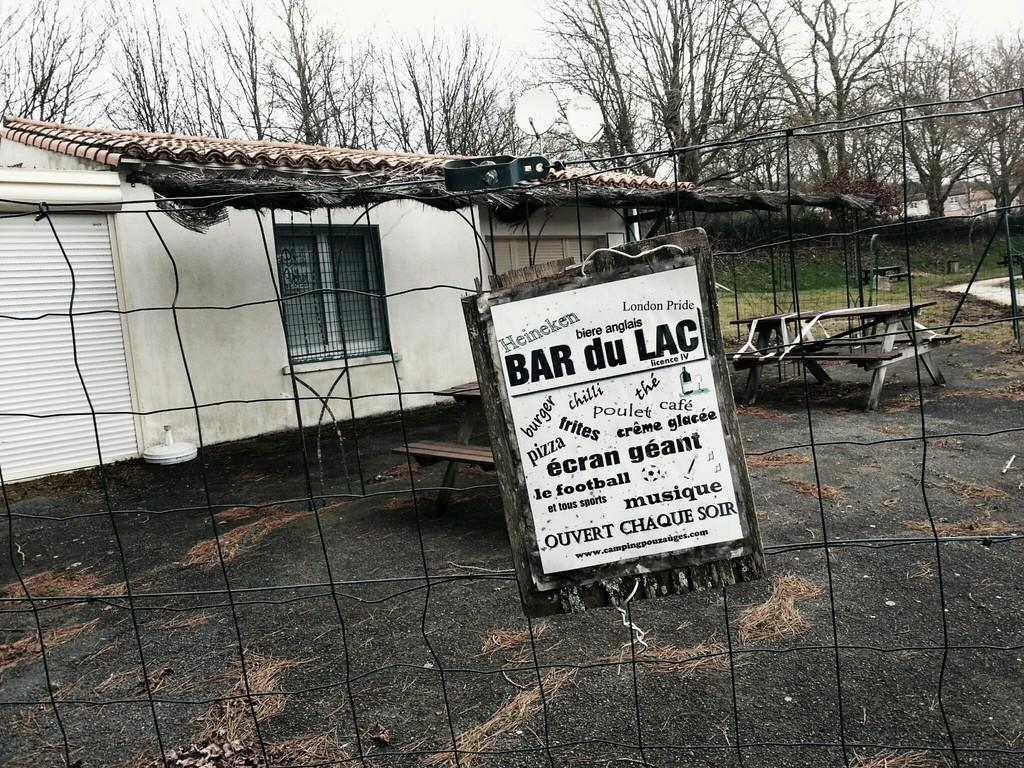Provide a one-sentence caption for the provided image. A sign that says BAR du LAC on a fence in front of a building. 